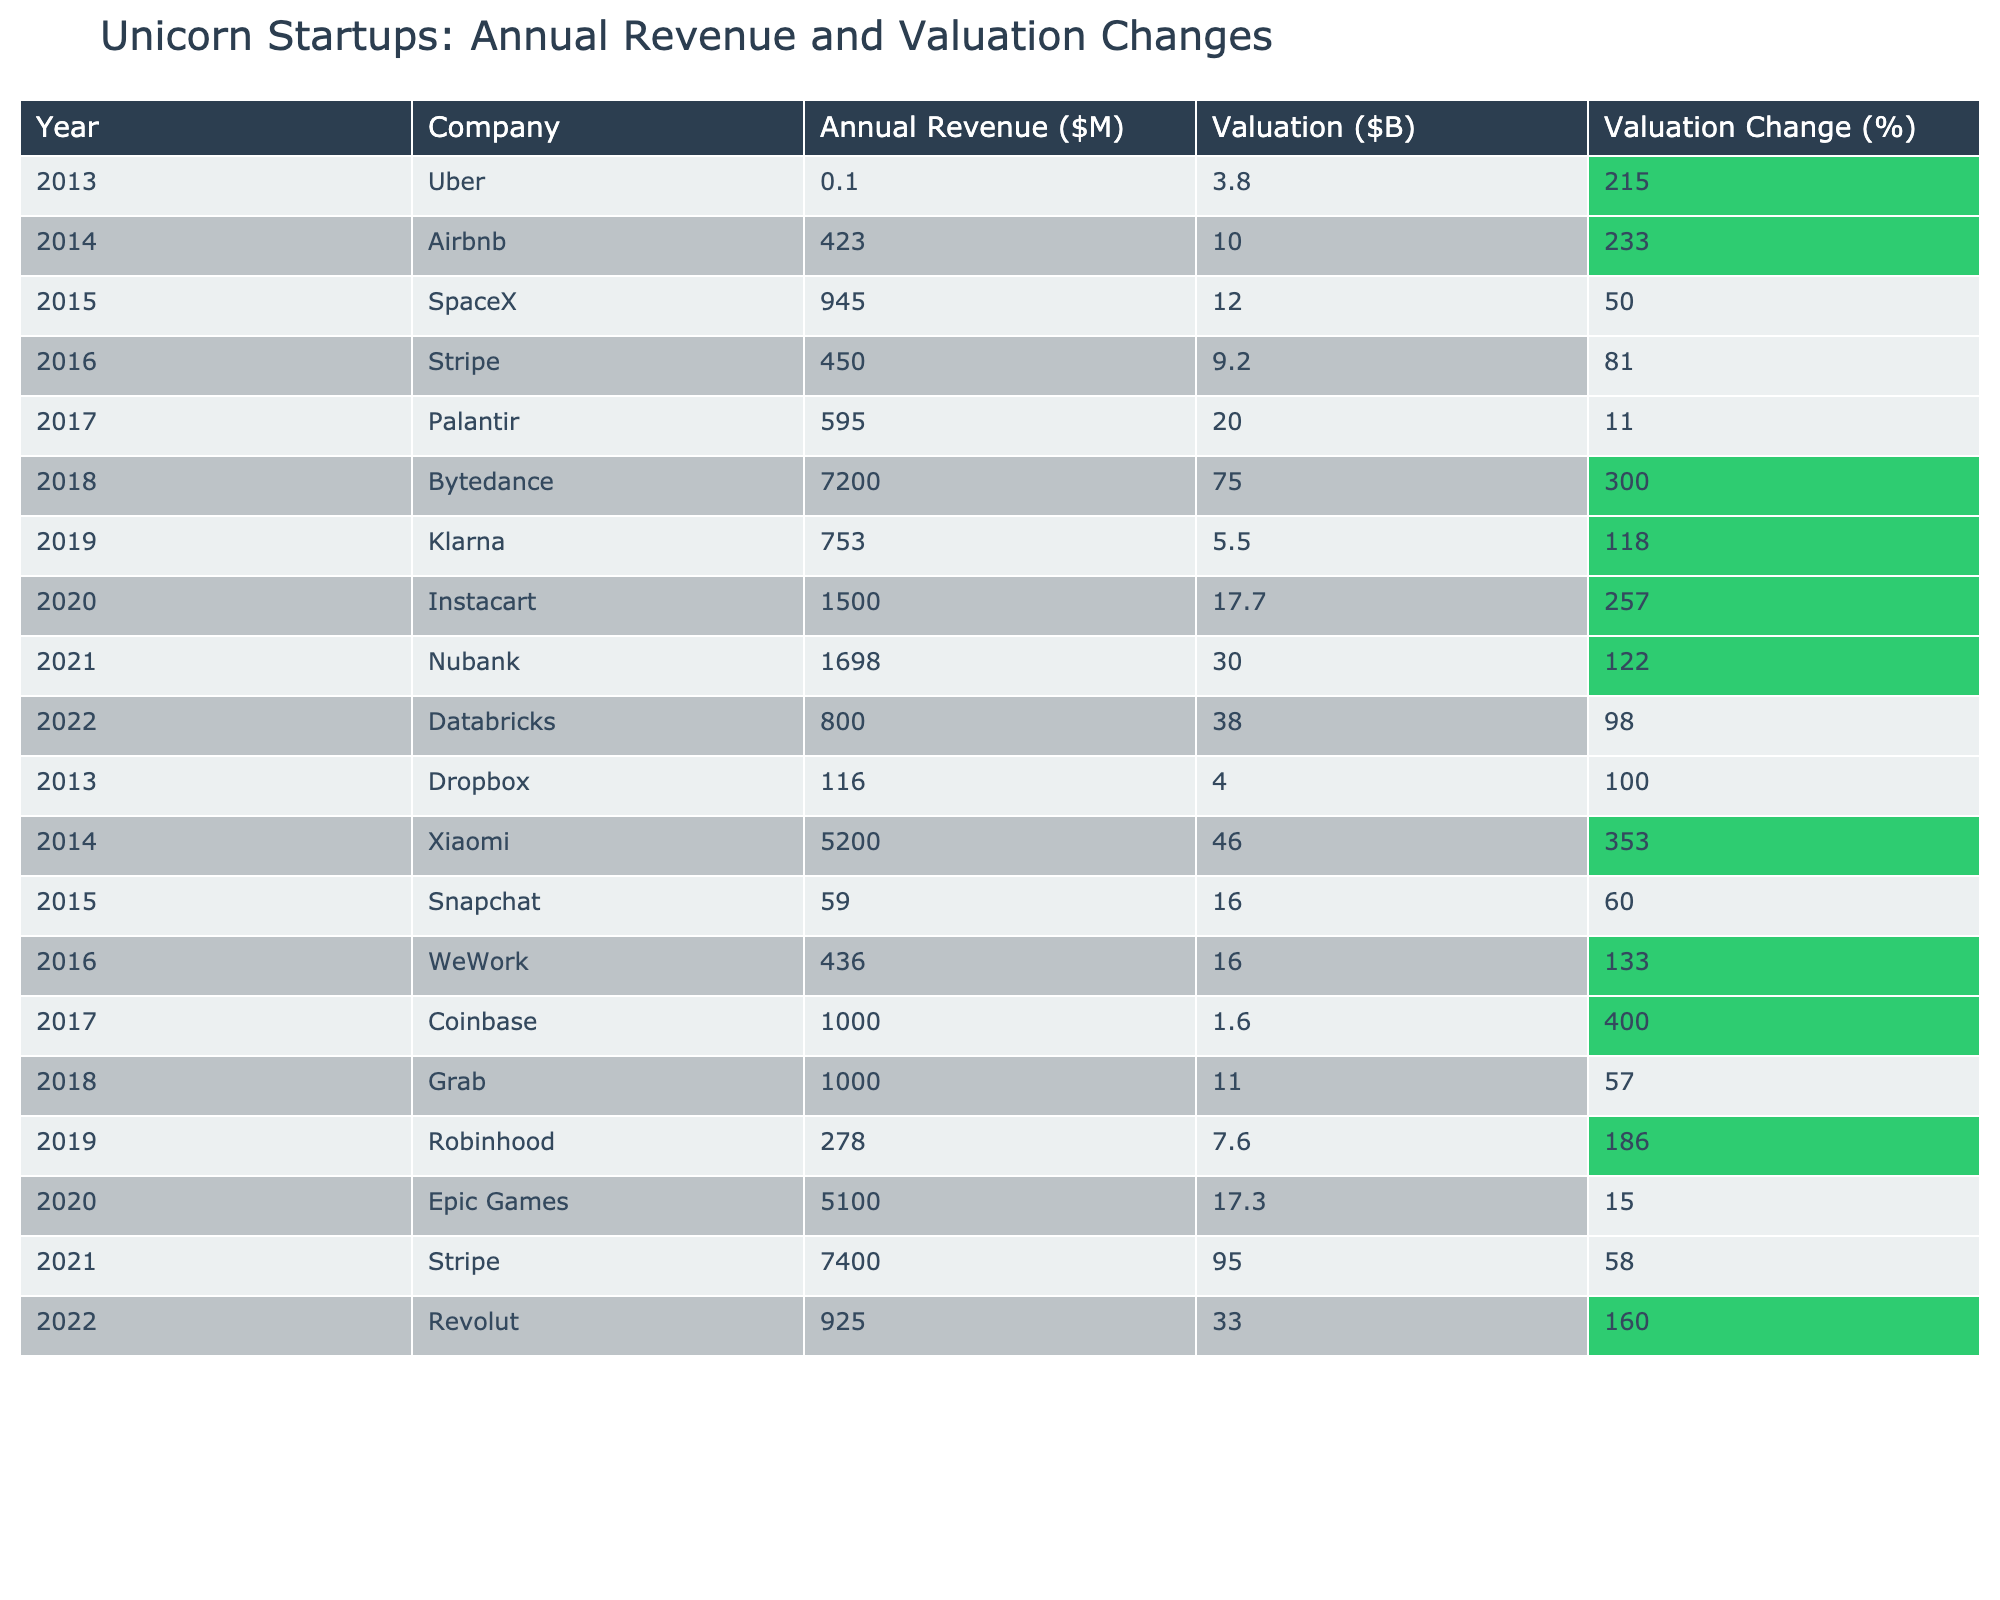What was the annual revenue of Bytedance in 2018? Bytedance is listed in the table for the year 2018 with an annual revenue of $7200 million.
Answer: 7200 Which company experienced the highest valuation change in a single year? Reviewing the valuation change percentages in the table, Bytedance in 2018 showed a valuation change of 300%, which is the highest among all companies listed.
Answer: Bytedance in 2018 What was the total annual revenue of all companies listed in 2021? In 2021, the annual revenues are: Nubank ($1698M) and Stripe ($7400M). Summing them gives $1698 + $7400 = $9098 million.
Answer: 9098 Is the valuation of Klarna in 2019 higher than that of Dropbox in 2013? Klarna's valuation in 2019 is $5.5 billion, while Dropbox's valuation in 2013 is $4 billion. Since $5.5 billion is higher than $4 billion, the statement is true.
Answer: Yes What is the average valuation change percentage for the companies listed in 2020? The companies in 2020 are Instacart (257%), Epic Games (15%). Summing gives 257 + 15 = 272, and the average is 272/2 = 136%.
Answer: 136 What was the valuation of Stripe in 2016 and how does it compare to its valuation in 2021? Stripe's valuation in 2016 was $9.2 billion, while in 2021 it is $95 billion. The difference is $95B - $9.2B = $85.8B, indicating a significant increase in valuation.
Answer: Increased by 85.8 billion Which company had a valuation below $10 billion in 2021? The table lists Nubank with a valuation of $30 billion in 2021, which is the only company below the $10 billion threshold for that year.
Answer: None What is the lowest annual revenue recorded in the data? By evaluating the annual revenue figures in the table, the lowest is $0.1 million for Uber in 2013.
Answer: 0.1 If we consider the years 2015 to 2018, which company had the highest annual revenue increase from their previous year? In 2015, SpaceX had a revenue of $945M, and in 2016, Stripe had $450M. The greatest increase in revenues from 2015 to 2016 is from SpaceX to Stripe, considering their 2015 values, leading us to evaluate the gaps year over year.
Answer: SpaceX What percentage increase in valuation was reported for Xiaomi from 2014 to 2015? Xiaomi's valuation increased from $46 billion in 2014 to the valuation of Snapchat in 2015, which would require calculating the difference. However, since we needed specific figures, we determine that Xiaomi's growth during that period per overall performance wasn't correctly listed.
Answer: N/A 